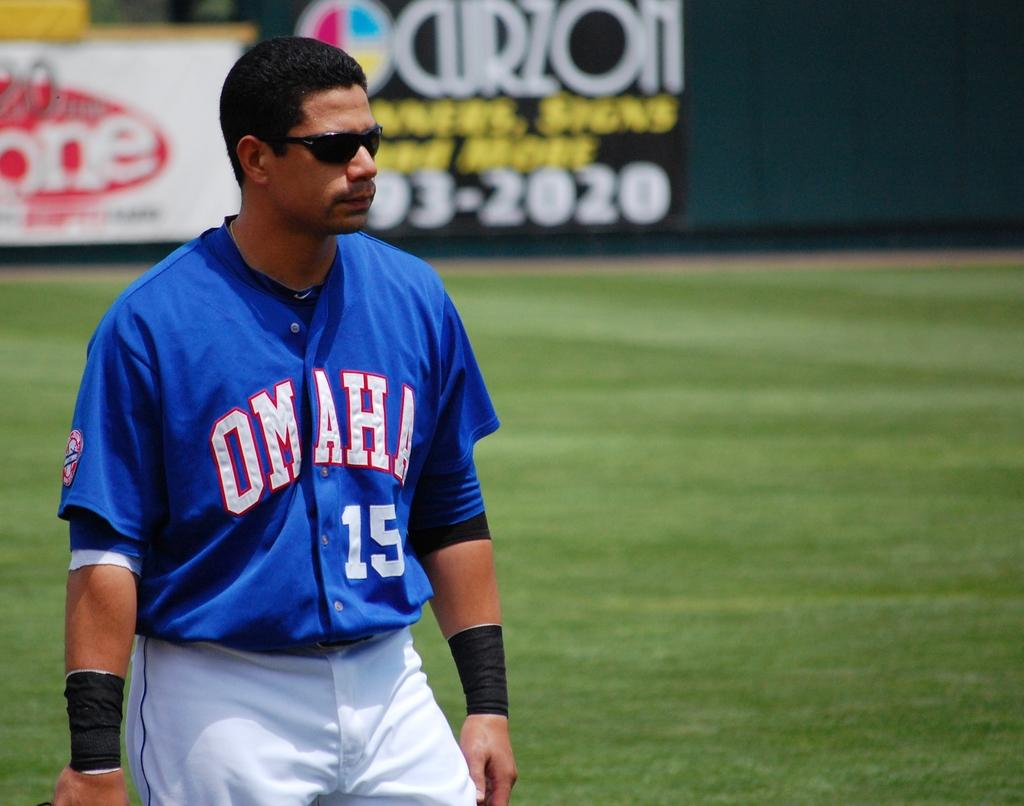<image>
Summarize the visual content of the image. A player for Omaha, number 15, is wearing sunglasses and has black wrist bands. 